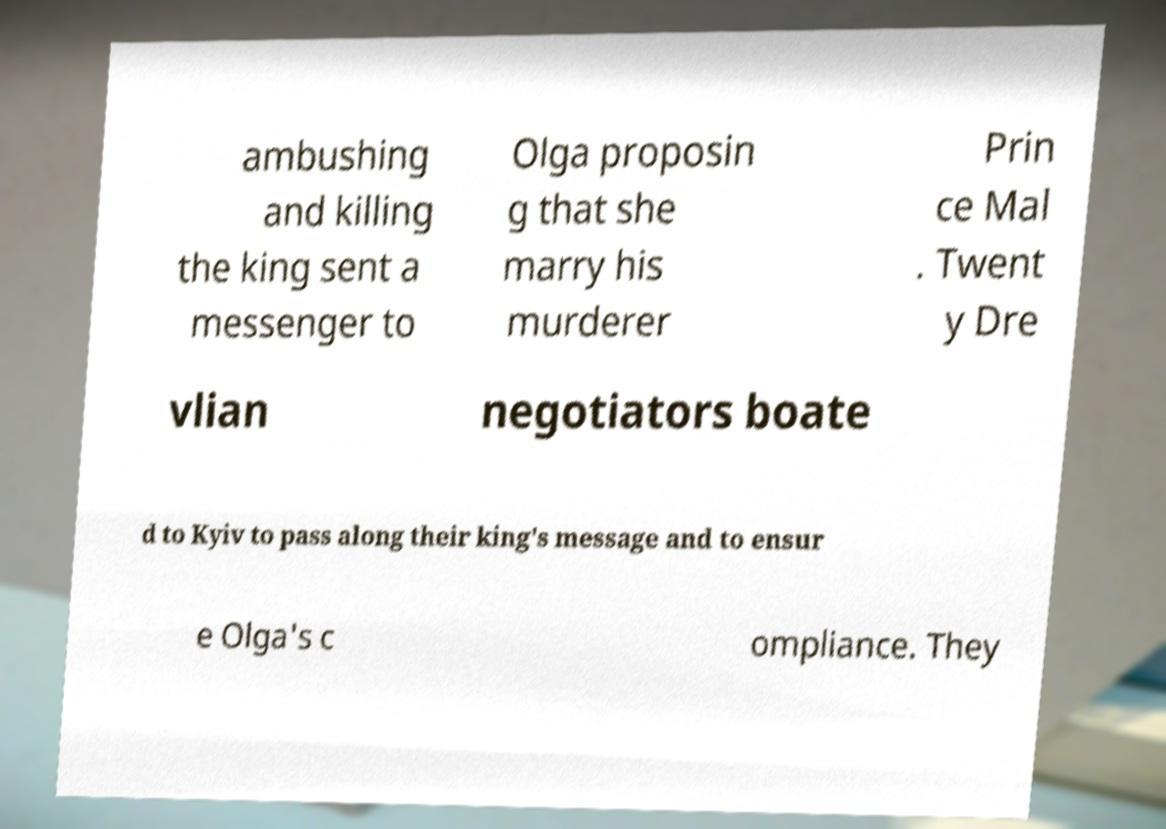There's text embedded in this image that I need extracted. Can you transcribe it verbatim? ambushing and killing the king sent a messenger to Olga proposin g that she marry his murderer Prin ce Mal . Twent y Dre vlian negotiators boate d to Kyiv to pass along their king's message and to ensur e Olga's c ompliance. They 